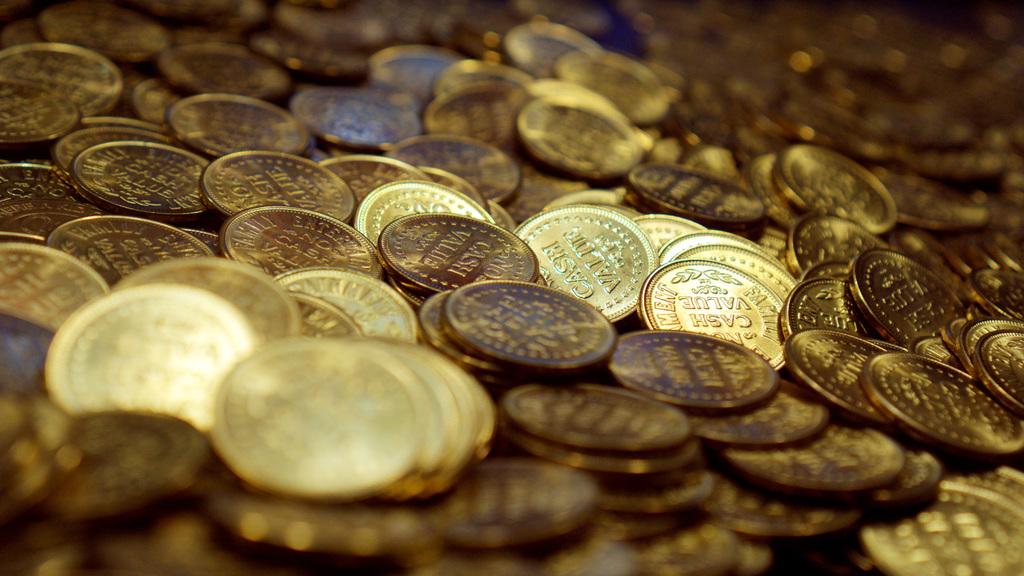What is the cash value of these coins?
Ensure brevity in your answer.  Unanswerable. Lot of many coins?
Offer a terse response. Yes. 